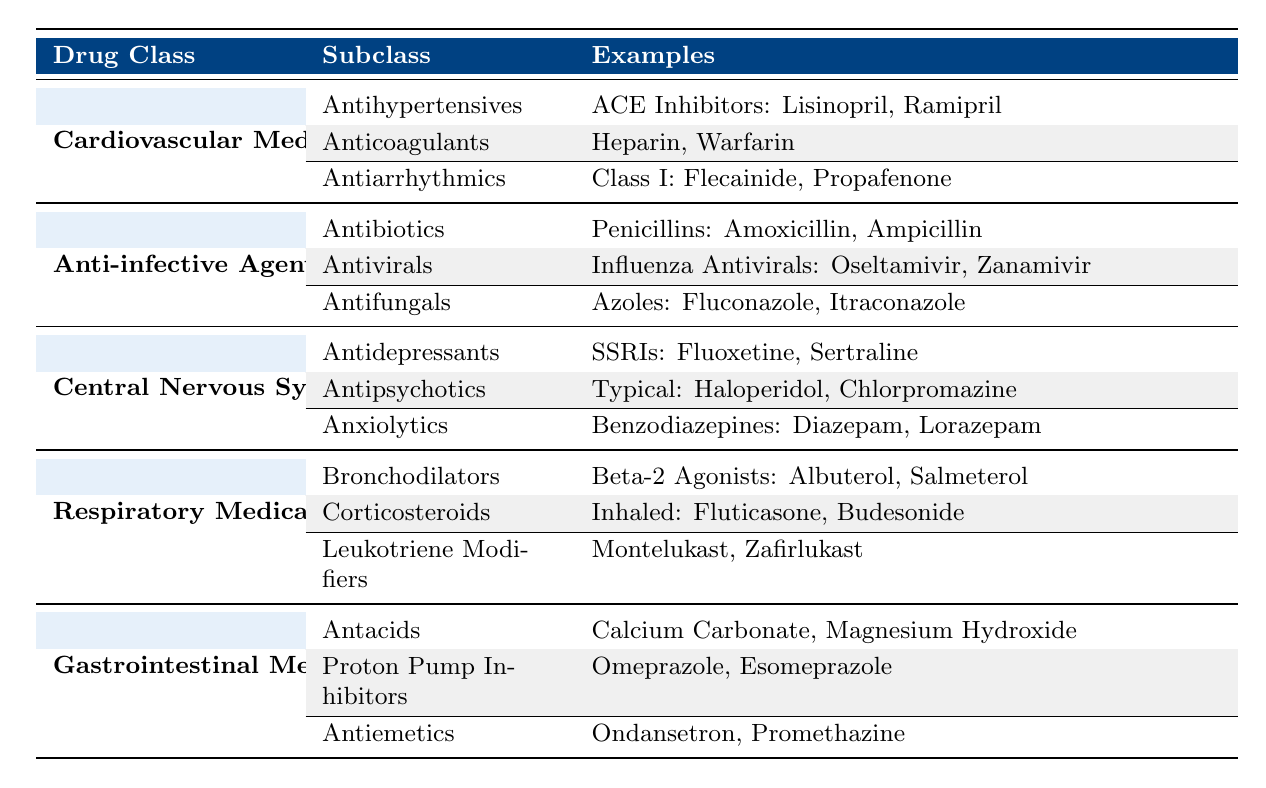What are the subclasses under Cardiovascular Medications? The table lists three subclasses under Cardiovascular Medications: Antihypertensives, Anticoagulants, and Antiarrhythmics.
Answer: Antihypertensives, Anticoagulants, Antiarrhythmics Which drug class includes Fluconazole? Fluconazole is listed under the Antifungals subclass, which is part of the Anti-infective Agents drug class.
Answer: Anti-infective Agents How many types of Antidepressants are mentioned? There are three types of Antidepressants mentioned in the table: SSRIs, SNRIs, and TCAs.
Answer: 3 Do all Anticoagulants have similar mechanisms of action? This question cannot be answered strictly from the table; however, generally, Anticoagulants do have mechanisms of action that target blood coagulation processes.
Answer: No (not strictly) What is the difference between Typical and Atypical Antipsychotics in terms of their categorization? Typical and Atypical Antipsychotics are listed as two separate subclasses under the Antipsychotics category in the Central Nervous System Medications drug class, indicating they belong to different groups based on their pharmacological profiles.
Answer: They are different subclasses How many subclasses are there for Respiratory Medications? The table lists three subclasses for Respiratory Medications: Bronchodilators, Corticosteroids, and Leukotriene Modifiers.
Answer: 3 Which class contains the medication Metoprolol? Metoprolol is an example of a medication listed under the Beta Blockers subclass, which is part of the Antihypertensives category in Cardiovascular Medications.
Answer: Cardiovascular Medications Name one drug that belongs to the class of Anti-infective Agents and has a subclass of Antibiotics. Amoxicillin is an example of an antibiotic that belongs to the Antibiotics subclass within the Anti-infective Agents class.
Answer: Amoxicillin Are there more subclasses under Central Nervous System Medications than under Gastrointestinal Medications? The table lists three subclasses for Central Nervous System Medications and three subclasses for Gastrointestinal Medications, making the number equal.
Answer: No What is the total number of examples listed under the subclass of Antiemetics? There are three examples under the subclass of Antiemetics: Ondansetron, Promethazine, and Metoclopramide.
Answer: 3 Which subclass of Respiratory Medications includes systemic medications? The subclass that includes systemic medications is Corticosteroids, which lists Prednisone and Dexamethasone under it.
Answer: Corticosteroids What two subclasses of Anti-infective Agents have medications that share the same mechanism against bacterial infections? Antibiotics (like Penicillins and Cephalosporins) and Antifungals both have agents that target microbial organisms, although they act against different types of pathogens.
Answer: Antibiotics and Antifungals 